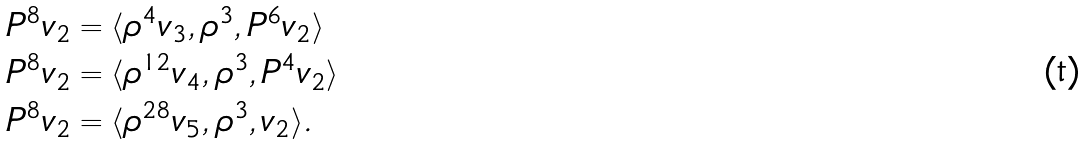Convert formula to latex. <formula><loc_0><loc_0><loc_500><loc_500>P ^ { 8 } v _ { 2 } & = \langle \rho ^ { 4 } v _ { 3 } , \rho ^ { 3 } , P ^ { 6 } v _ { 2 } \rangle \\ P ^ { 8 } v _ { 2 } & = \langle \rho ^ { 1 2 } v _ { 4 } , \rho ^ { 3 } , P ^ { 4 } v _ { 2 } \rangle \\ P ^ { 8 } v _ { 2 } & = \langle \rho ^ { 2 8 } v _ { 5 } , \rho ^ { 3 } , v _ { 2 } \rangle .</formula> 